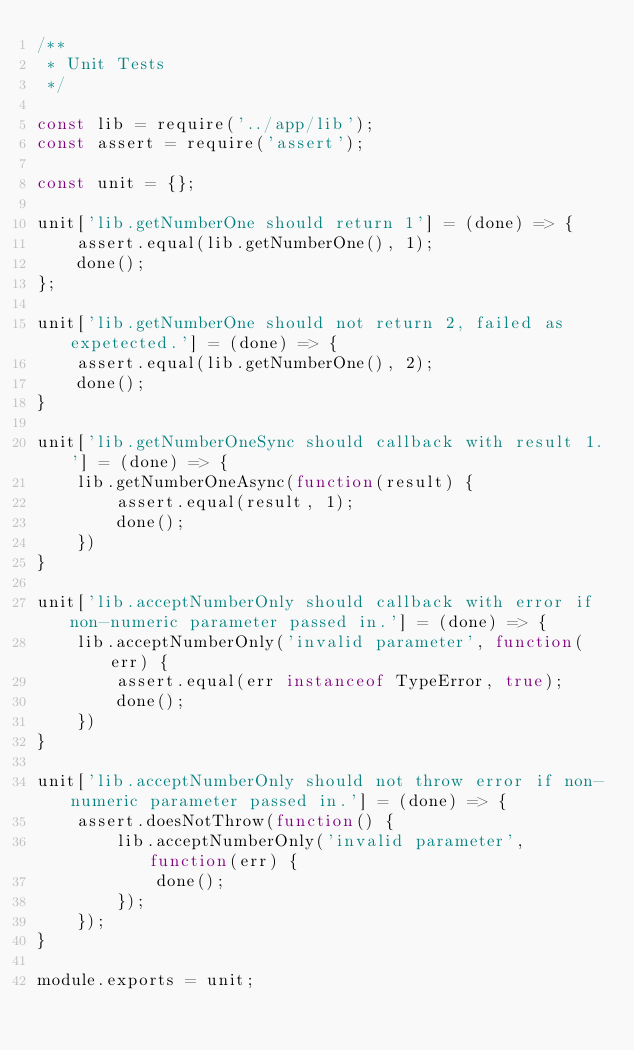<code> <loc_0><loc_0><loc_500><loc_500><_JavaScript_>/**
 * Unit Tests
 */

const lib = require('../app/lib');
const assert = require('assert');

const unit = {};

unit['lib.getNumberOne should return 1'] = (done) => {
    assert.equal(lib.getNumberOne(), 1);
    done();
};

unit['lib.getNumberOne should not return 2, failed as expetected.'] = (done) => {
    assert.equal(lib.getNumberOne(), 2);
    done();
}

unit['lib.getNumberOneSync should callback with result 1.'] = (done) => {
    lib.getNumberOneAsync(function(result) {
        assert.equal(result, 1);
        done();
    })
}

unit['lib.acceptNumberOnly should callback with error if non-numeric parameter passed in.'] = (done) => {
    lib.acceptNumberOnly('invalid parameter', function(err) {
        assert.equal(err instanceof TypeError, true);
        done();
    })
}

unit['lib.acceptNumberOnly should not throw error if non-numeric parameter passed in.'] = (done) => {
    assert.doesNotThrow(function() {
        lib.acceptNumberOnly('invalid parameter', function(err) {
            done();
        });
    });
}

module.exports = unit;</code> 